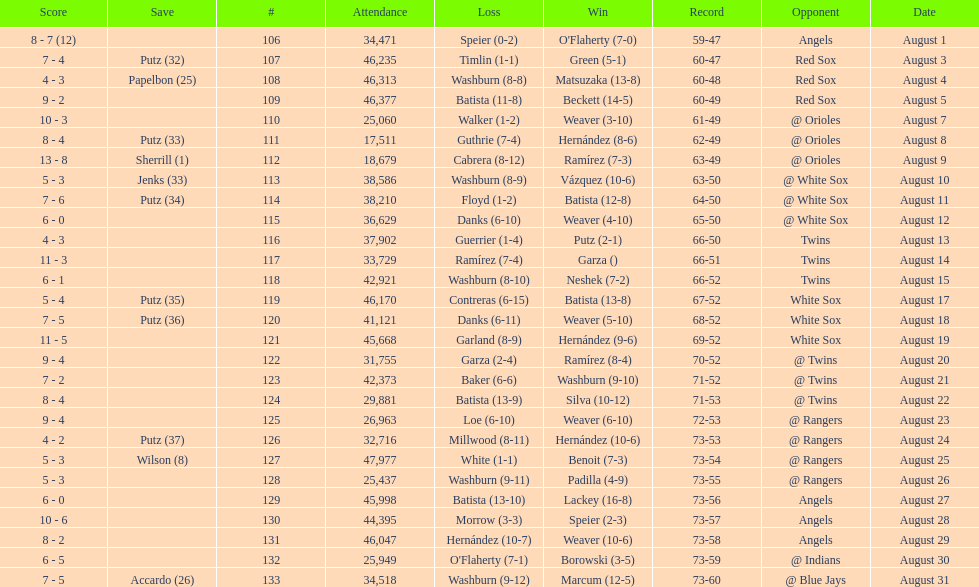Games above 30,000 in attendance 21. 